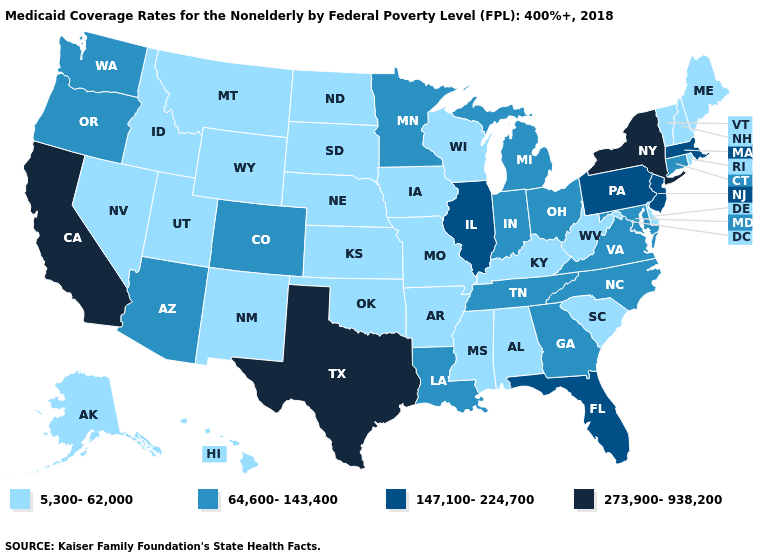Which states have the lowest value in the Northeast?
Be succinct. Maine, New Hampshire, Rhode Island, Vermont. Name the states that have a value in the range 64,600-143,400?
Write a very short answer. Arizona, Colorado, Connecticut, Georgia, Indiana, Louisiana, Maryland, Michigan, Minnesota, North Carolina, Ohio, Oregon, Tennessee, Virginia, Washington. What is the lowest value in the South?
Write a very short answer. 5,300-62,000. Does Illinois have the same value as Pennsylvania?
Give a very brief answer. Yes. Name the states that have a value in the range 147,100-224,700?
Give a very brief answer. Florida, Illinois, Massachusetts, New Jersey, Pennsylvania. What is the value of Massachusetts?
Keep it brief. 147,100-224,700. Does the map have missing data?
Give a very brief answer. No. What is the highest value in states that border Alabama?
Concise answer only. 147,100-224,700. Among the states that border Indiana , does Kentucky have the lowest value?
Answer briefly. Yes. What is the value of Alabama?
Give a very brief answer. 5,300-62,000. What is the value of Arkansas?
Concise answer only. 5,300-62,000. How many symbols are there in the legend?
Write a very short answer. 4. How many symbols are there in the legend?
Quick response, please. 4. What is the value of North Dakota?
Keep it brief. 5,300-62,000. 